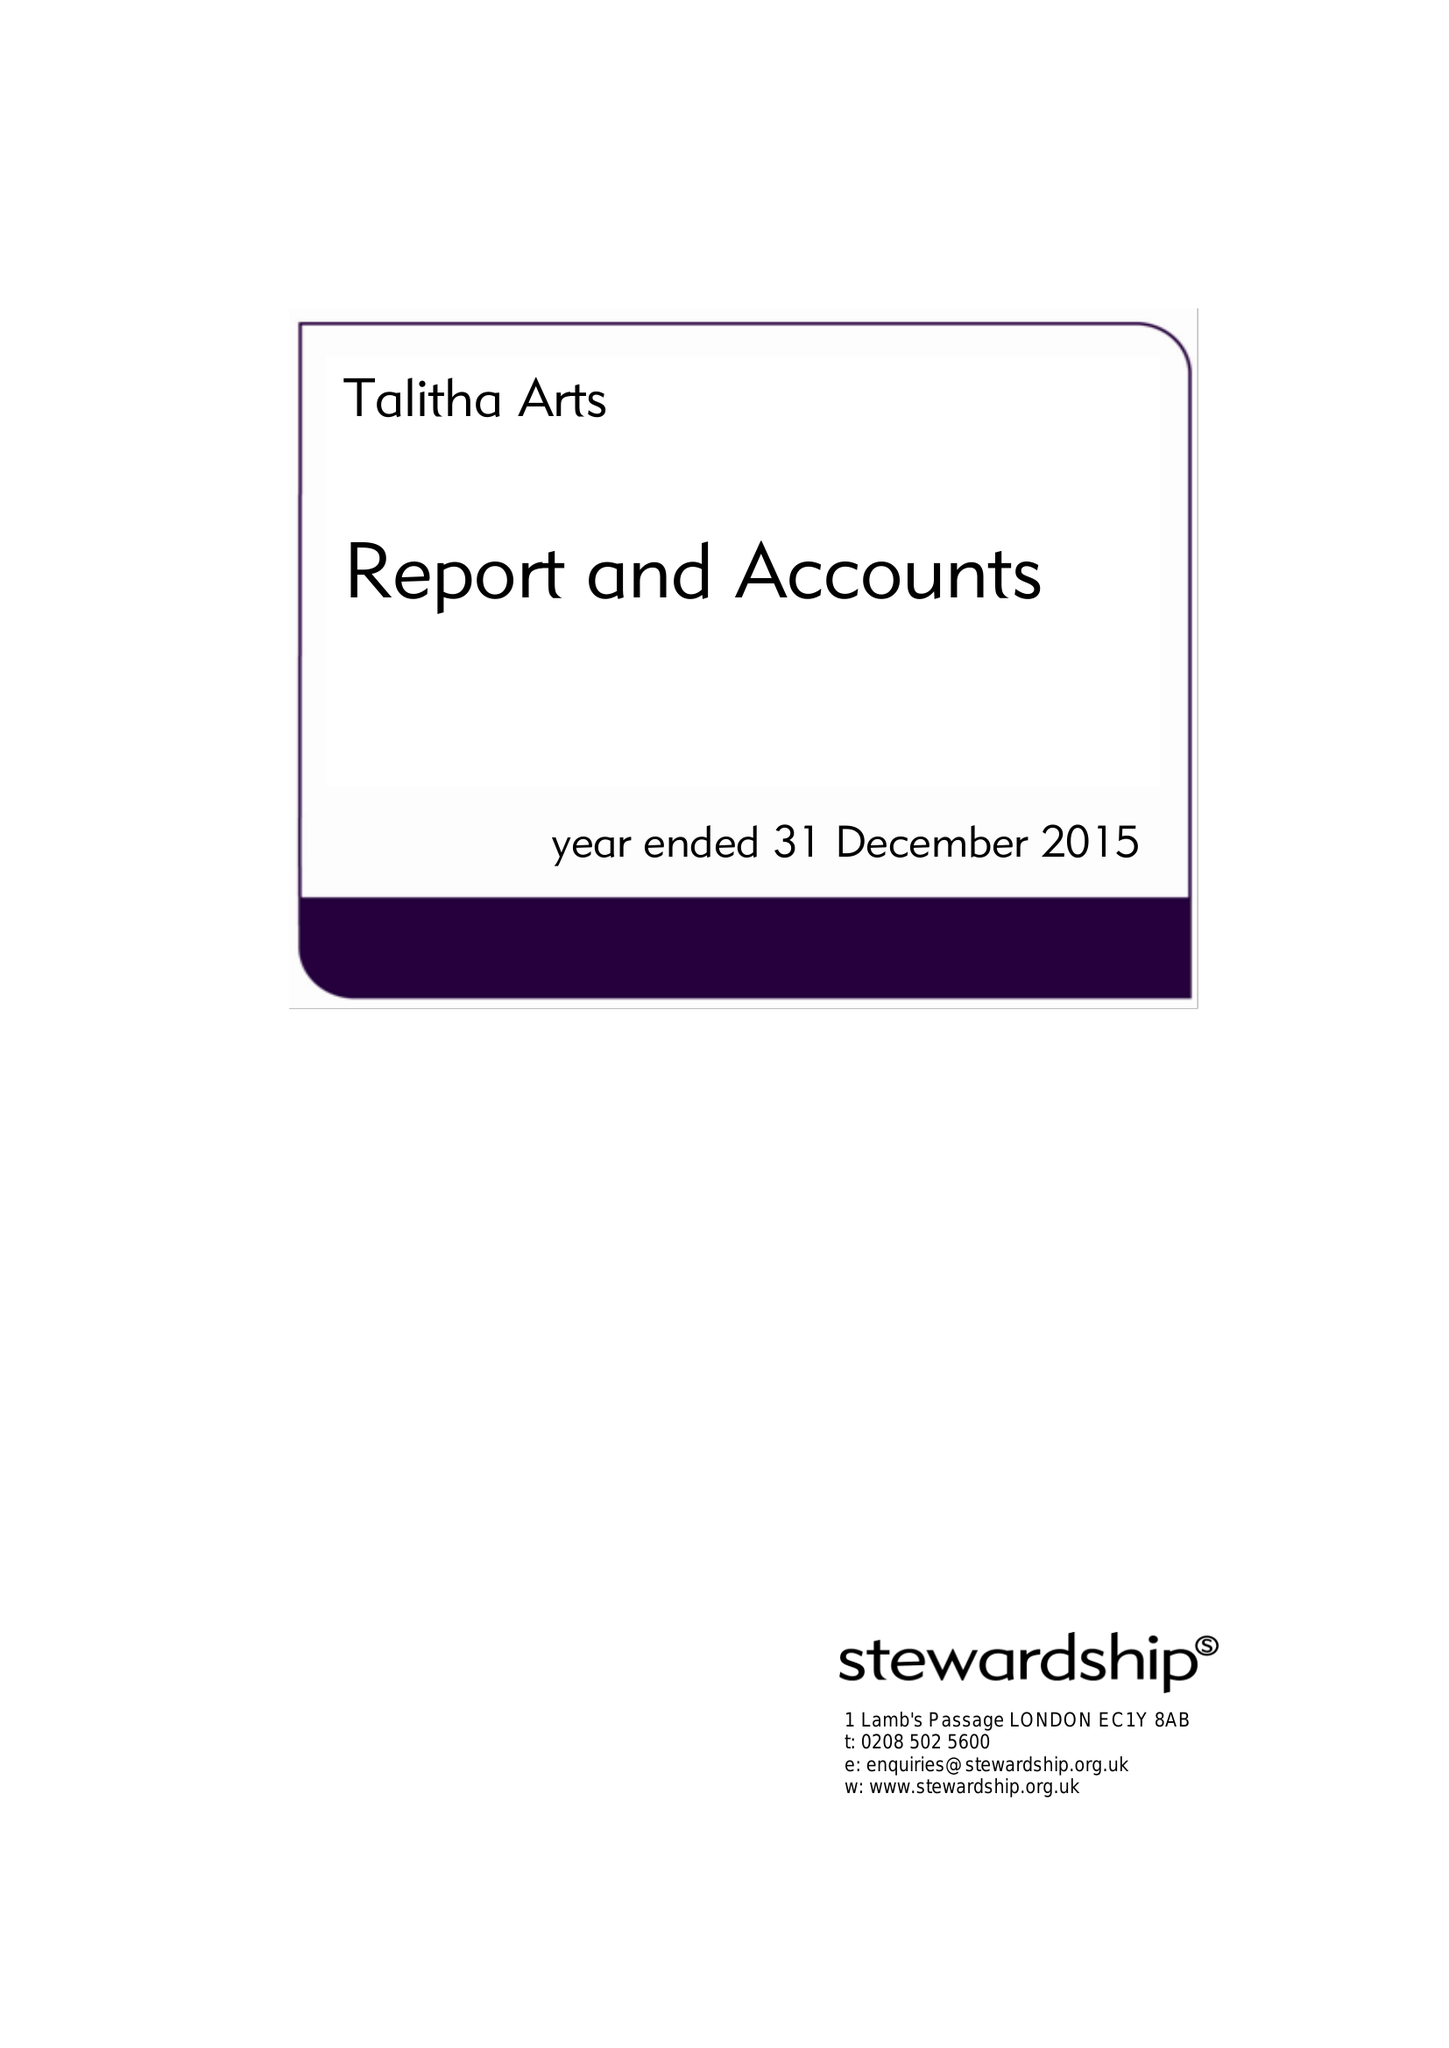What is the value for the charity_number?
Answer the question using a single word or phrase. 1162475 